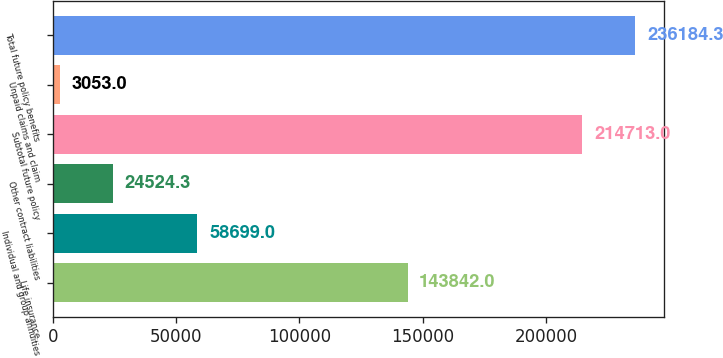Convert chart to OTSL. <chart><loc_0><loc_0><loc_500><loc_500><bar_chart><fcel>Life insurance<fcel>Individual and group annuities<fcel>Other contract liabilities<fcel>Subtotal future policy<fcel>Unpaid claims and claim<fcel>Total future policy benefits<nl><fcel>143842<fcel>58699<fcel>24524.3<fcel>214713<fcel>3053<fcel>236184<nl></chart> 